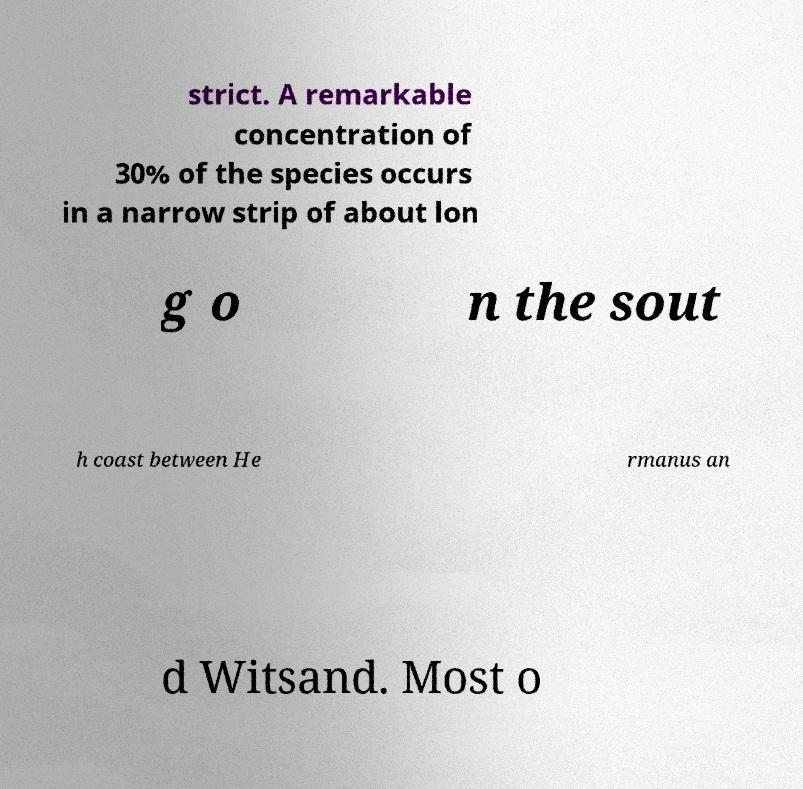Could you assist in decoding the text presented in this image and type it out clearly? strict. A remarkable concentration of 30% of the species occurs in a narrow strip of about lon g o n the sout h coast between He rmanus an d Witsand. Most o 